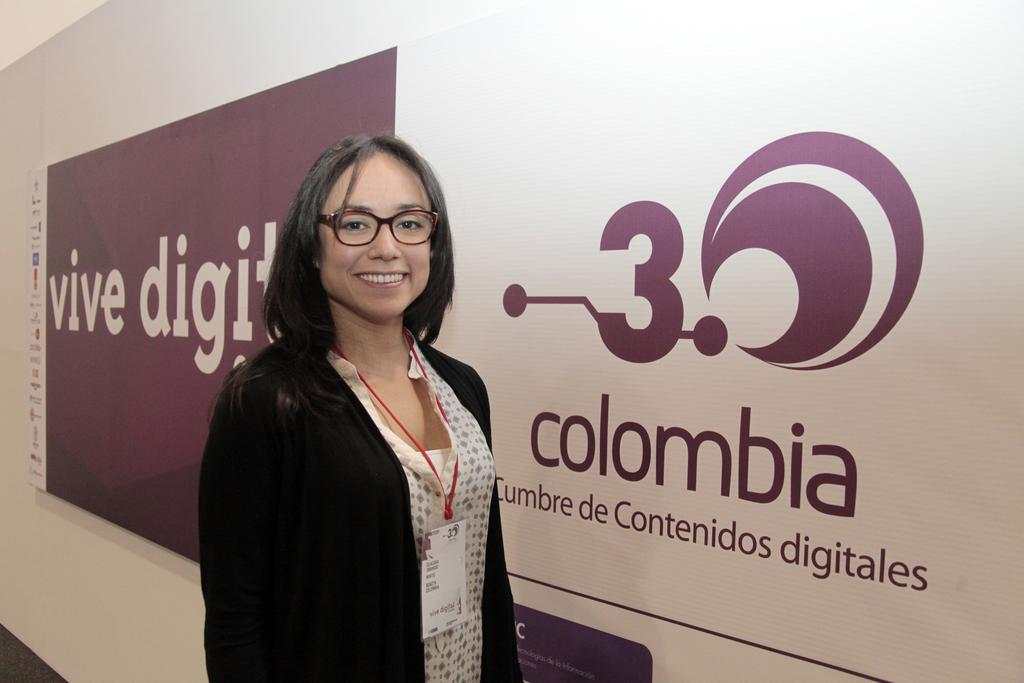What is the main subject of the image? There is a woman standing in the image. Can you describe any additional elements in the background of the image? There is a banner with text on it in the background of the image. What type of food is the woman teaching in the image? There is no indication in the image that the woman is teaching or that food is involved. 